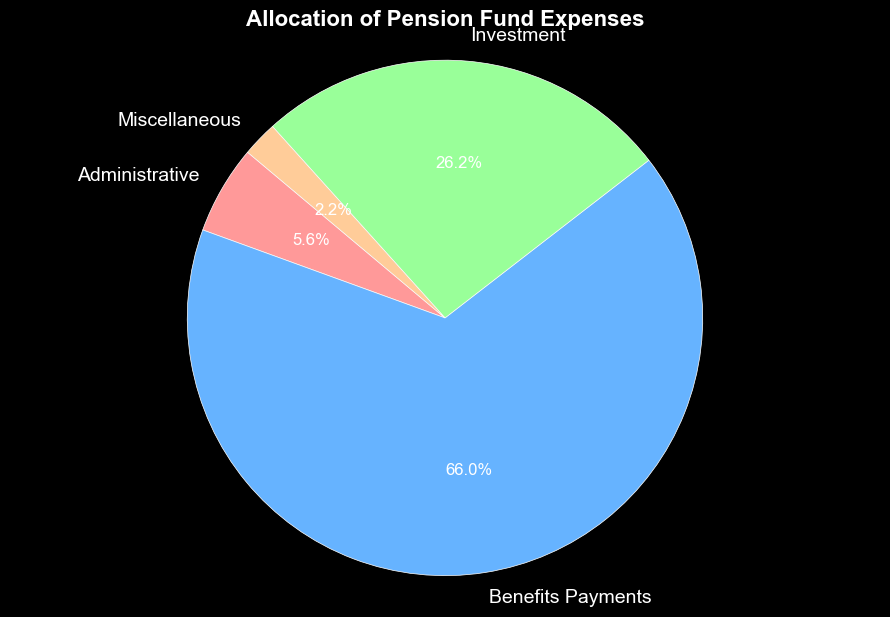What percentage of the pension fund expenses is allocated to Investment? By looking at the pie chart, find the segment labeled "Investment" and check its corresponding percentage.
Answer: 34.6% Which category has the smallest allocation in the pension fund expenses? Identify the smallest slice of the pie chart by visually comparing the sizes of all slices and noting the label.
Answer: Miscellaneous How much more is spent on Benefit Payments compared to Administrative expenses? First, identify the percentages for Benefit Payments and Administrative expenses from the pie chart. Then, convert these percentages to their monetary values using the total sum if needed and finally subtract the smaller value from the larger one. The percentages are 55.1% and 5.6% respectively.
Answer: 25.5 million What is the sum of the allocations for Administrative and Miscellaneous categories? Identify the percentages for Administrative and Miscellaneous categories, which are 7.3% and 2.0% respectively. Add these percentages together to get the total.
Answer: 9.3% Is the allocation for Benefits Payments more than 50% of the total expenses? Look at the pie chart and determine if the percentage for Benefit Payments is greater than 50%. For Benefit Payments, the percentage is 55.1%.
Answer: Yes How does the Administrative expense compare to the Miscellaneous expense? Locate the slices corresponding to Administrative and Miscellaneous expenses on the pie chart. Compare the sizes of these slices to determine the relation. The percentages are 7.3% and 2.0% respectively.
Answer: Administrative is larger What percentage of the pension fund is allocated to non-Benefit Payments categories? Identify the percentage for Benefit Payments (55.1%) and subtract it from 100%.
Answer: 44.9% Which category, excluding Benefits Payments, has the highest allocation? Exclude the Benefits Payments segment and compare the remaining three sections visually. The Investment segment is the largest among the remaining ones.
Answer: Investment Are the allocations for Administrative and Miscellaneous expenses together less than the allocation for Investment? Add the percentages of Administrative (7.3%) and Miscellaneous (2.0%) and compare their sum to the Investment percentage (34.6%).
Answer: Yes What can you infer about the distribution pattern of pension fund expenses from the largest expense to the smallest? The largest allocation goes to Benefit Payments (55.1%), followed by Investment (34.6%), Administrative (7.3%), and the smallest is Miscellaneous (2.0%).
Answer: Benefit Payments > Investment > Administrative > Miscellaneous 